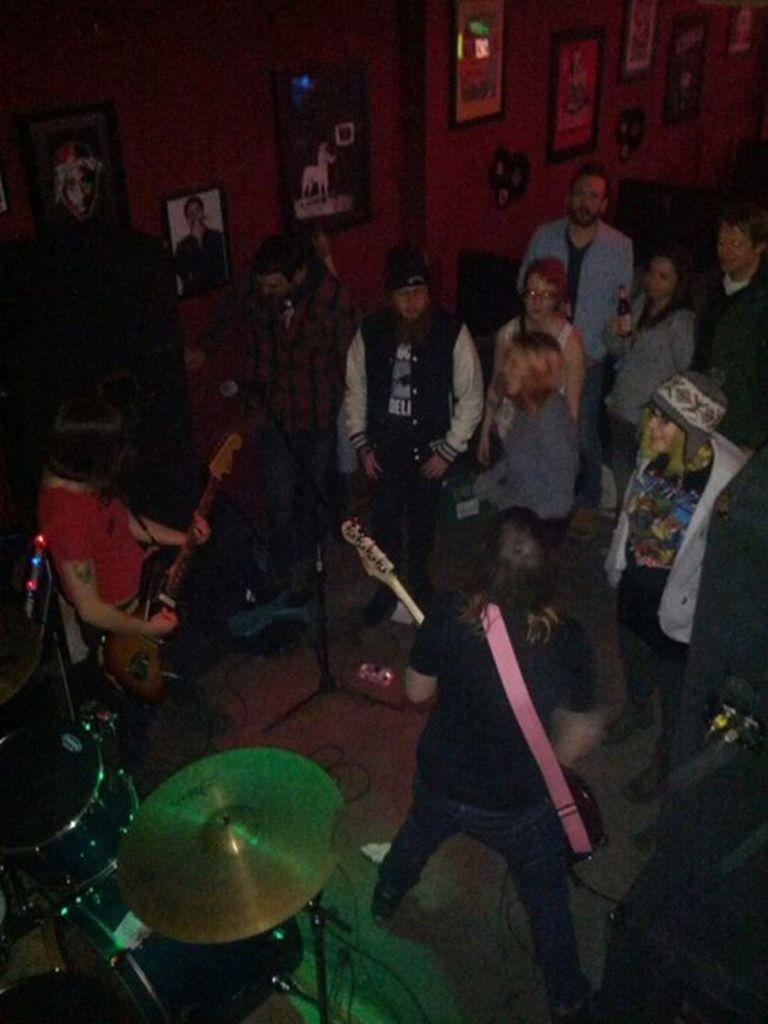How many people are in the image? There is a group of people in the image. What are the people in the image doing? The people are standing. Are any of the people playing musical instruments? Yes, two persons are playing musical instruments. What can be seen in the background of the image? There are posters, a photo frame, and a wall in the background of the image. What type of poison is being used to flavor the eggnog in the image? There is no eggnog or poison present in the image. What is the end result of the people's actions in the image? The image does not depict a specific outcome or end result; it simply shows a group of people standing and playing musical instruments. 